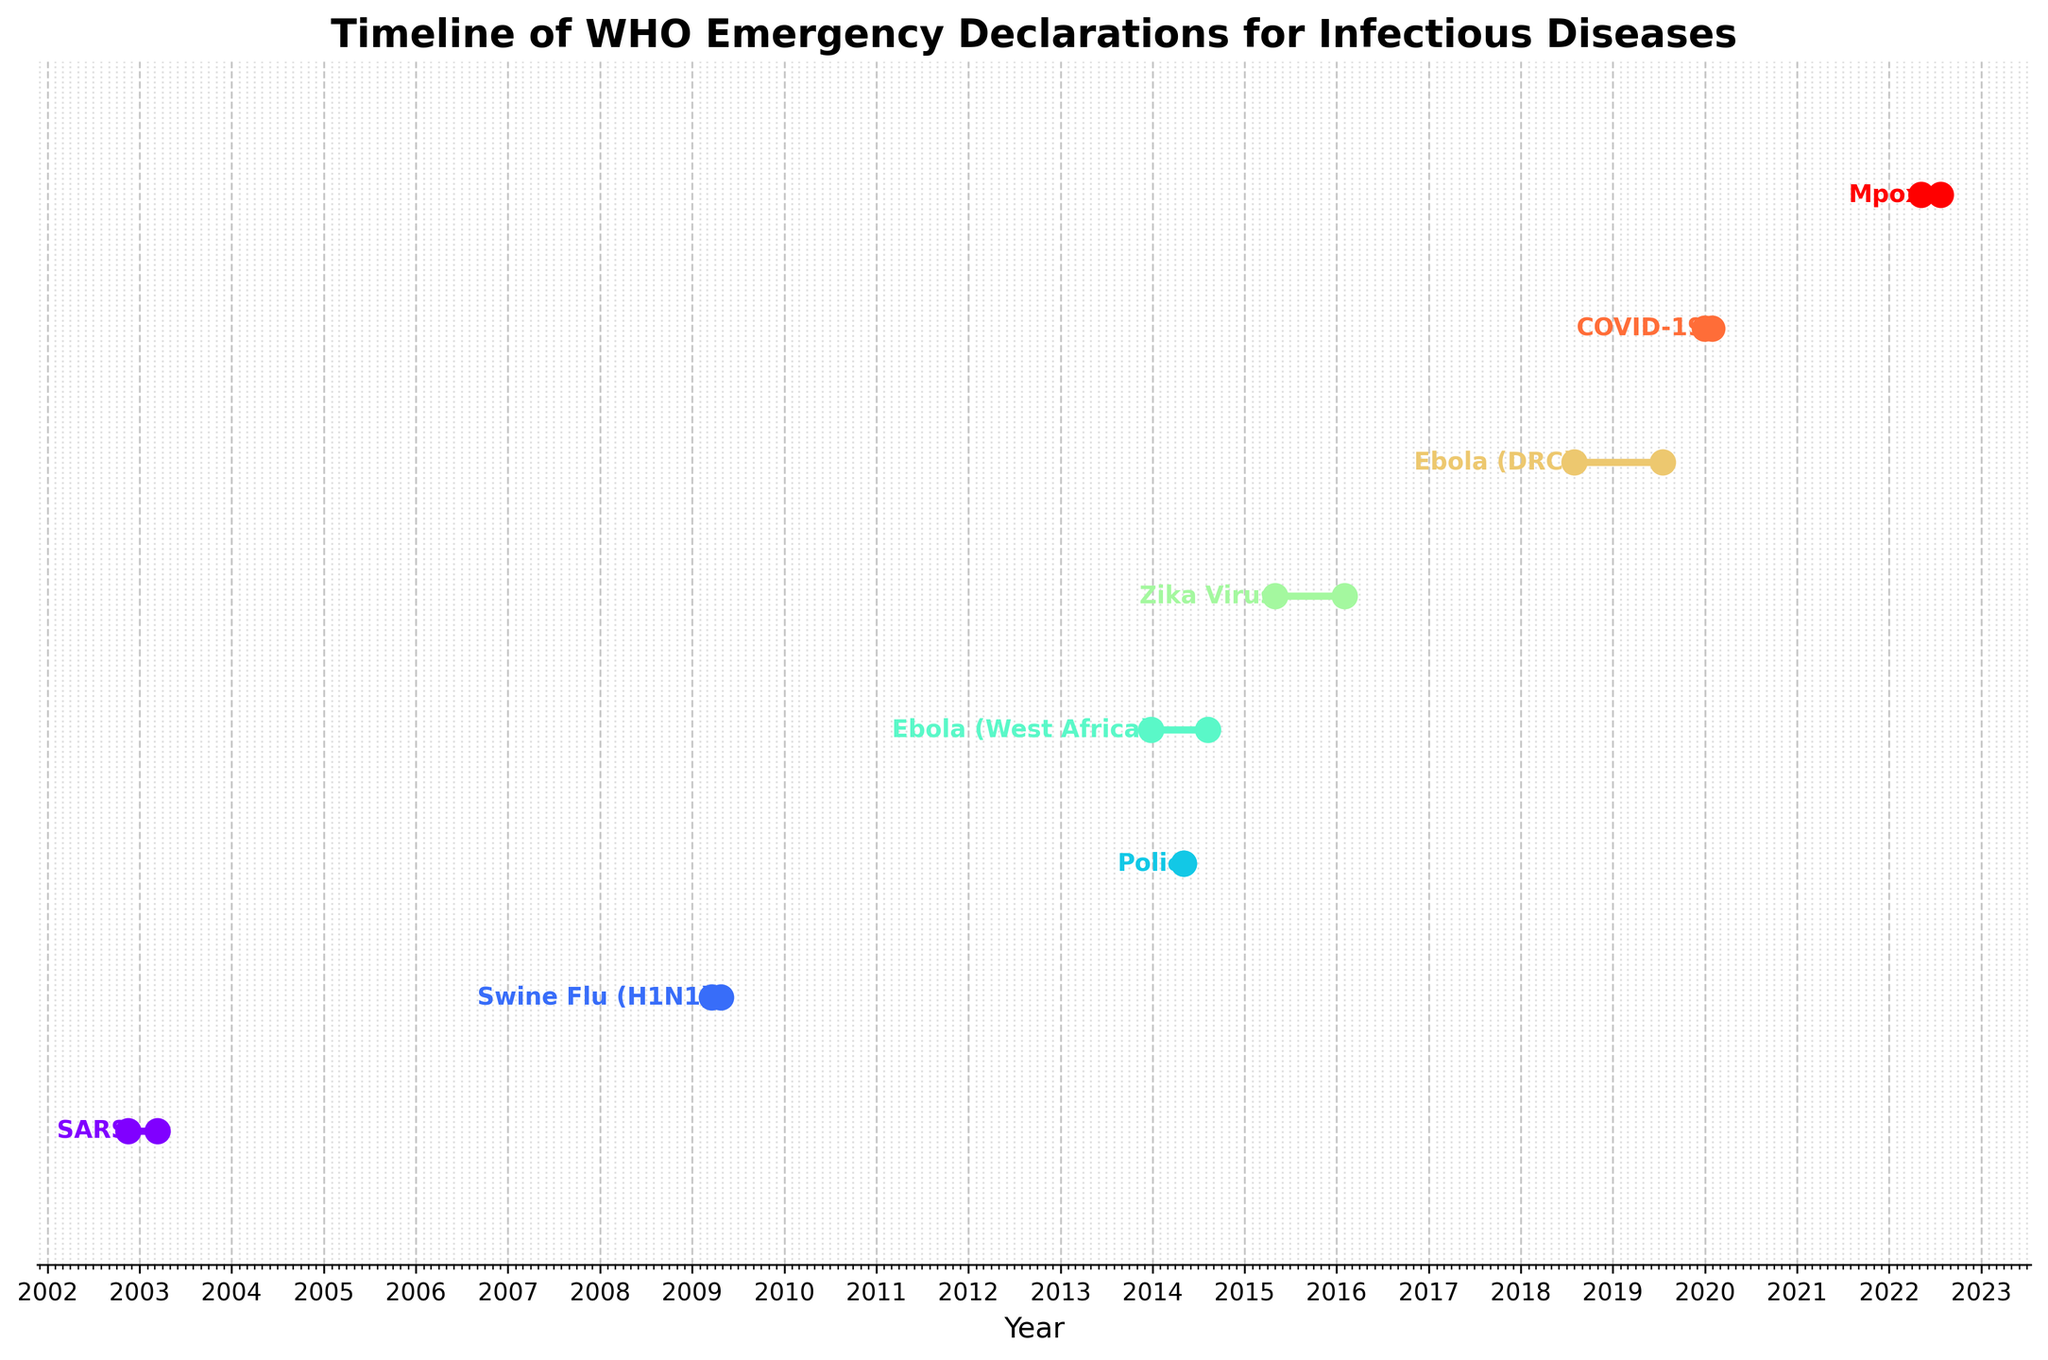What is the title of the figure? The title of the figure is usually mentioned at the top. Here, it is "Timeline of WHO Emergency Declarations for Infectious Diseases".
Answer: Timeline of WHO Emergency Declarations for Infectious Diseases How many events are displayed in the figure? Count the different events listed on the y-axis in the figure. There are eight events listed.
Answer: Eight What color scheme is used in the figure? The colors in the figure are used to distinguish between different events. It uses a rainbow color scheme.
Answer: Rainbow What year did the SARS outbreak start according to the figure? Look at the beginning of the timeline for the SARS event. It is marked in 2002.
Answer: 2002 Which event had the shortest time between the outbreak date and the WHO declaration date? Identify the event where the length of the line between the two dates is shortest. It is Polio, which had both dates the same.
Answer: Polio What is the total time span between the initial outbreak of SARS and the declaration date of the Mpox outbreak? Calculate the number of years between the SARS outbreak start in 2002 and the Mpox WHO declaration in 2022, which totals 20 years.
Answer: 20 years On average, how many months have passed between the initial outbreak and the WHO declaration for all events? Calculate the time difference in months for each event and then find the average. For example: SARS: 4 months, Swine Flu: 1 month, Polio: 0 months, Ebola (West Africa): 8 months, Zika Virus: 9 months, Ebola (DRC): 12 months, COVID-19: 1 month, Mpox: 2 months. Average = (4+1+0+8+9+12+1+2)/8 = 4.625 months.
Answer: 4.625 months Which event had a longer time between the initial outbreak and WHO declaration: Zika Virus or Ebola (West Africa)? Compare the lengths of the lines for Zika Virus and Ebola (West Africa). Zika Virus took longer.
Answer: Zika Virus Was the response time for COVID-19 faster or slower than for SARS? Compare the lengths of the lines for COVID-19 and SARS. COVID-19 had a shorter line, meaning a faster response.
Answer: Faster Which had a longer delay between the outbreak and the declaration date: Ebola (DRC) or Swine Flu (H1N1)? Compare the lengths of the lines for Ebola (DRC) and Swine Flu (H1N1). Ebola (DRC) had a longer delay.
Answer: Ebola (DRC) How is the data for each event represented in the figure? Each event is represented by a horizontal line between its outbreak date and its WHO declaration date on a time scale, with markers at both ends.
Answer: Horizontal lines with markers What information does the x-axis of the figure represent? The x-axis represents the timeline in years, showing when events occurred and were declared.
Answer: Timeline in years 